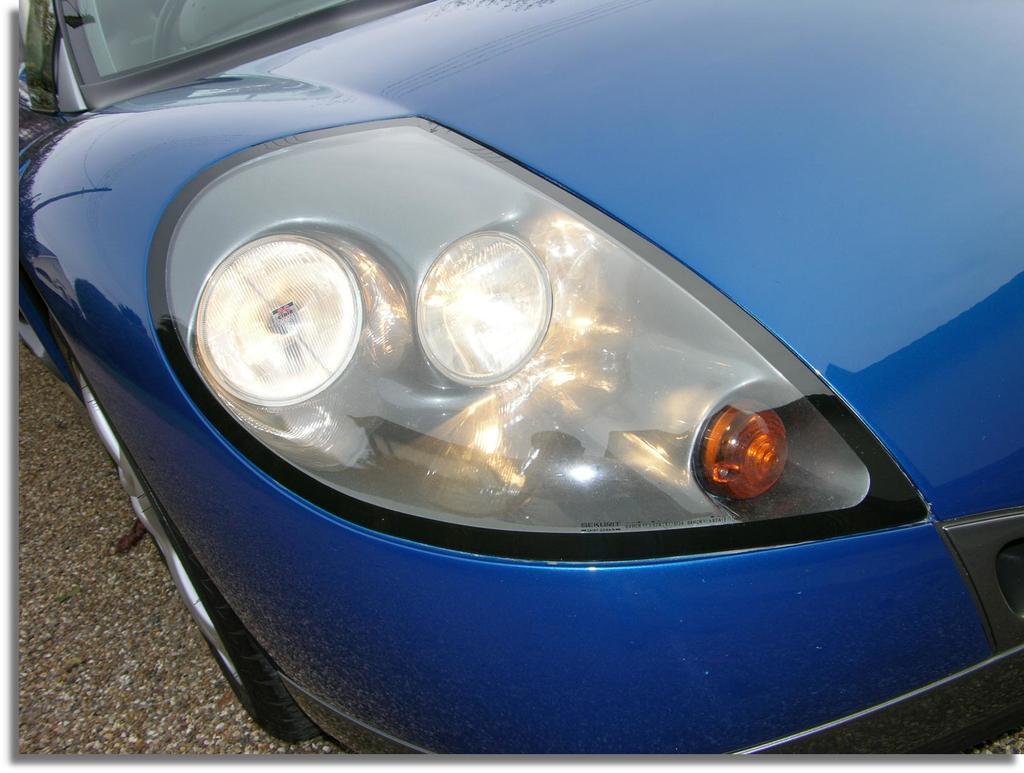Could you give a brief overview of what you see in this image? In the foreground of the image, there is a truncated car on the ground. 